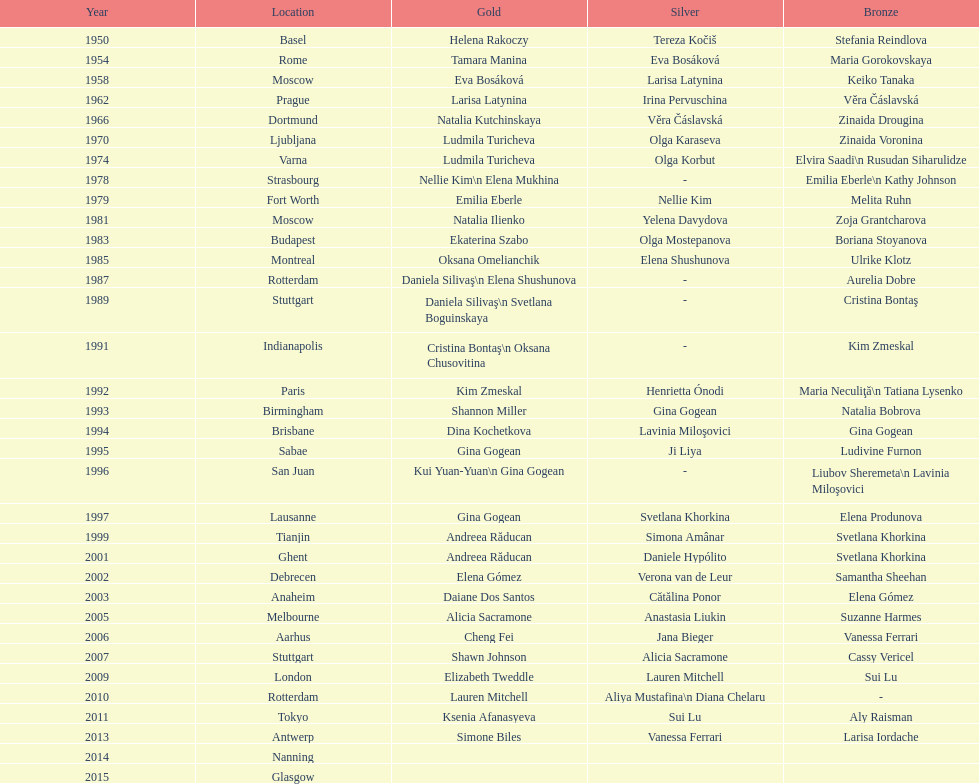Until 2013, what is the cumulative sum of floor exercise gold medals achieved by american women during the world championships? 5. Help me parse the entirety of this table. {'header': ['Year', 'Location', 'Gold', 'Silver', 'Bronze'], 'rows': [['1950', 'Basel', 'Helena Rakoczy', 'Tereza Kočiš', 'Stefania Reindlova'], ['1954', 'Rome', 'Tamara Manina', 'Eva Bosáková', 'Maria Gorokovskaya'], ['1958', 'Moscow', 'Eva Bosáková', 'Larisa Latynina', 'Keiko Tanaka'], ['1962', 'Prague', 'Larisa Latynina', 'Irina Pervuschina', 'Věra Čáslavská'], ['1966', 'Dortmund', 'Natalia Kutchinskaya', 'Věra Čáslavská', 'Zinaida Drougina'], ['1970', 'Ljubljana', 'Ludmila Turicheva', 'Olga Karaseva', 'Zinaida Voronina'], ['1974', 'Varna', 'Ludmila Turicheva', 'Olga Korbut', 'Elvira Saadi\\n Rusudan Siharulidze'], ['1978', 'Strasbourg', 'Nellie Kim\\n Elena Mukhina', '-', 'Emilia Eberle\\n Kathy Johnson'], ['1979', 'Fort Worth', 'Emilia Eberle', 'Nellie Kim', 'Melita Ruhn'], ['1981', 'Moscow', 'Natalia Ilienko', 'Yelena Davydova', 'Zoja Grantcharova'], ['1983', 'Budapest', 'Ekaterina Szabo', 'Olga Mostepanova', 'Boriana Stoyanova'], ['1985', 'Montreal', 'Oksana Omelianchik', 'Elena Shushunova', 'Ulrike Klotz'], ['1987', 'Rotterdam', 'Daniela Silivaş\\n Elena Shushunova', '-', 'Aurelia Dobre'], ['1989', 'Stuttgart', 'Daniela Silivaş\\n Svetlana Boguinskaya', '-', 'Cristina Bontaş'], ['1991', 'Indianapolis', 'Cristina Bontaş\\n Oksana Chusovitina', '-', 'Kim Zmeskal'], ['1992', 'Paris', 'Kim Zmeskal', 'Henrietta Ónodi', 'Maria Neculiţă\\n Tatiana Lysenko'], ['1993', 'Birmingham', 'Shannon Miller', 'Gina Gogean', 'Natalia Bobrova'], ['1994', 'Brisbane', 'Dina Kochetkova', 'Lavinia Miloşovici', 'Gina Gogean'], ['1995', 'Sabae', 'Gina Gogean', 'Ji Liya', 'Ludivine Furnon'], ['1996', 'San Juan', 'Kui Yuan-Yuan\\n Gina Gogean', '-', 'Liubov Sheremeta\\n Lavinia Miloşovici'], ['1997', 'Lausanne', 'Gina Gogean', 'Svetlana Khorkina', 'Elena Produnova'], ['1999', 'Tianjin', 'Andreea Răducan', 'Simona Amânar', 'Svetlana Khorkina'], ['2001', 'Ghent', 'Andreea Răducan', 'Daniele Hypólito', 'Svetlana Khorkina'], ['2002', 'Debrecen', 'Elena Gómez', 'Verona van de Leur', 'Samantha Sheehan'], ['2003', 'Anaheim', 'Daiane Dos Santos', 'Cătălina Ponor', 'Elena Gómez'], ['2005', 'Melbourne', 'Alicia Sacramone', 'Anastasia Liukin', 'Suzanne Harmes'], ['2006', 'Aarhus', 'Cheng Fei', 'Jana Bieger', 'Vanessa Ferrari'], ['2007', 'Stuttgart', 'Shawn Johnson', 'Alicia Sacramone', 'Cassy Vericel'], ['2009', 'London', 'Elizabeth Tweddle', 'Lauren Mitchell', 'Sui Lu'], ['2010', 'Rotterdam', 'Lauren Mitchell', 'Aliya Mustafina\\n Diana Chelaru', '-'], ['2011', 'Tokyo', 'Ksenia Afanasyeva', 'Sui Lu', 'Aly Raisman'], ['2013', 'Antwerp', 'Simone Biles', 'Vanessa Ferrari', 'Larisa Iordache'], ['2014', 'Nanning', '', '', ''], ['2015', 'Glasgow', '', '', '']]} 